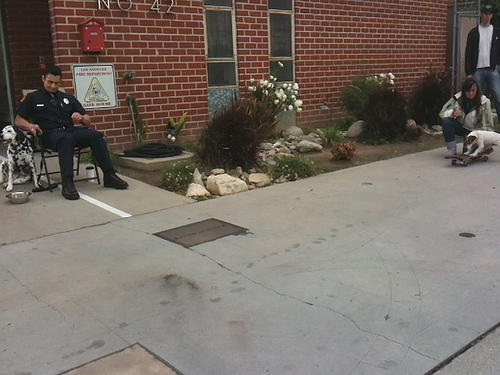Identify and read out the text in this image. NO 